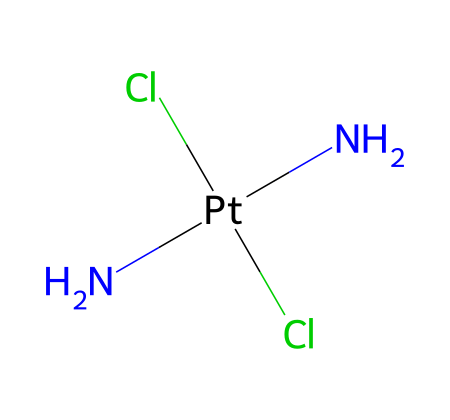What is the central metal atom in cisplatin? The SMILES structure indicates that platinum (Pt) is the central metal atom, as it is directly attached to the surrounding ligands.
Answer: platinum How many chloride ions are present in cisplatin? Looking at the SMILES representation, there are two Cl atoms listed, indicating that there are two chloride ions in the compound.
Answer: 2 What type of ligands are attached to the platinum atom? The structure shows two nitrogen atoms (N) and two chloride ions (Cl) attached to the platinum atom, making them the ligands in the coordination complex.
Answer: ammonium and chloride What is the oxidation state of the platinum in cisplatin? The platinum is in a +2 oxidation state. This can be inferred from the formal charges of the attached ligands, where two chloride ions each contribute -1 charge, and the two ammine groups balance this charge.
Answer: +2 What characteristic of cisplatin allows it to act as a chemotherapy agent? The presence of the platinum atom enables the formation of DNA cross-links, critical for inhibiting cancer cell division and, therefore, its therapeutic efficacy in chemotherapy.
Answer: DNA cross-linking How many total atoms are in the cisplatin molecule? By counting the atoms represented in the SMILES — 1 platinum, 2 nitrogen, and 2 chloride — the total number of atoms in cisplatin is five.
Answer: 5 